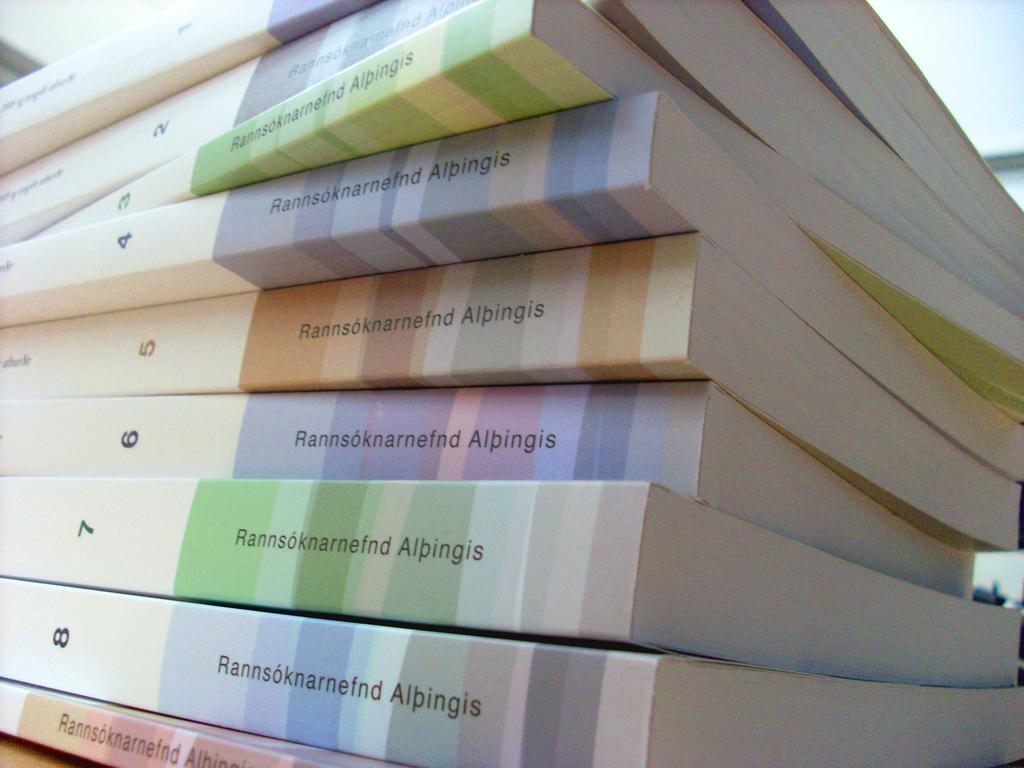What number is written on the bottom book?
Your answer should be very brief. 8. 